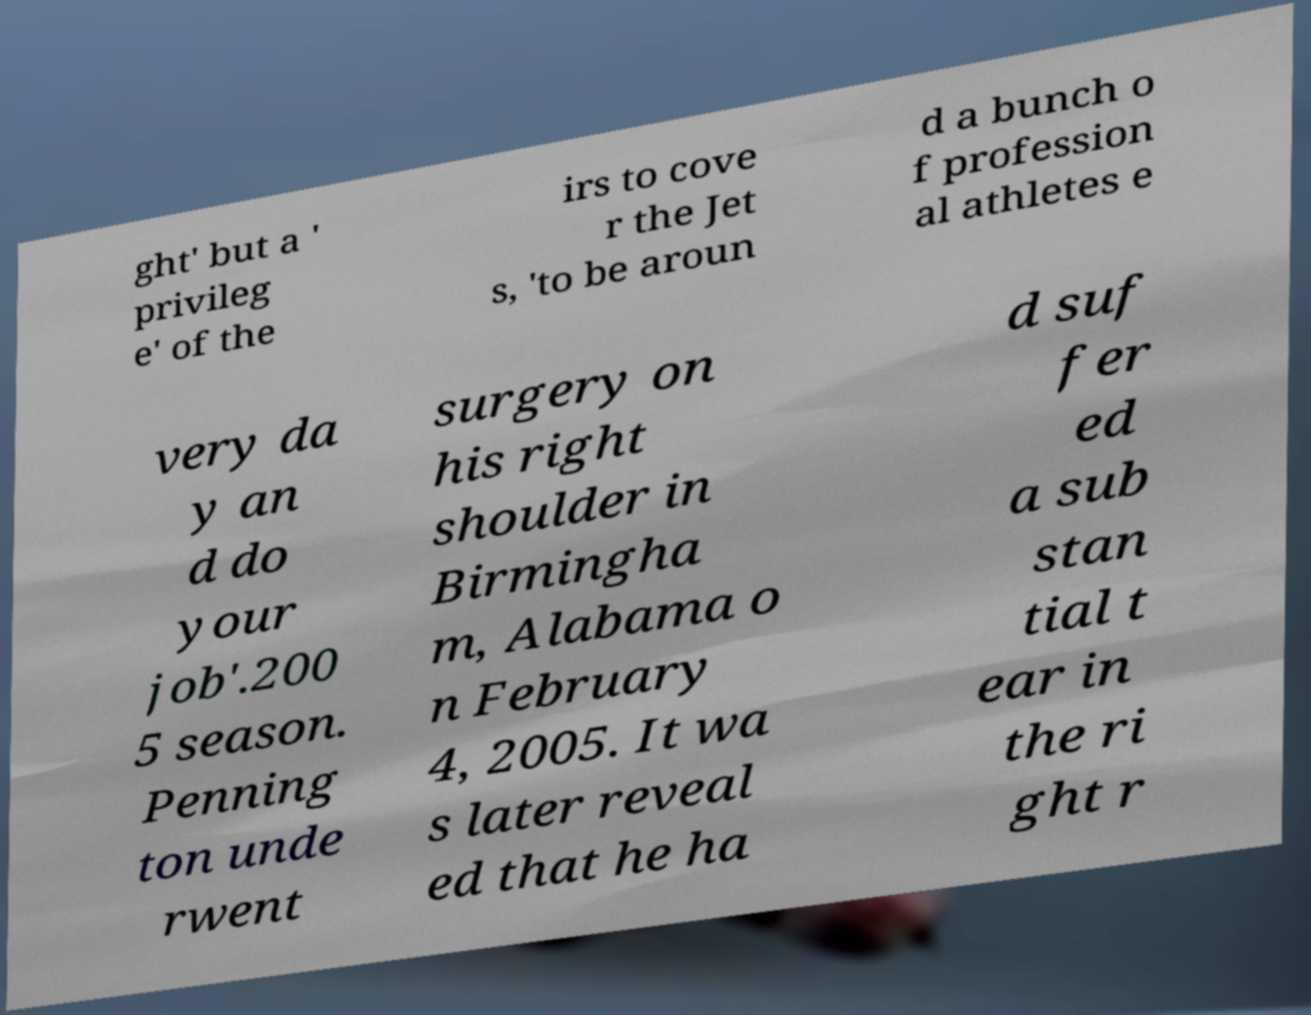Can you accurately transcribe the text from the provided image for me? ght' but a ' privileg e' of the irs to cove r the Jet s, 'to be aroun d a bunch o f profession al athletes e very da y an d do your job'.200 5 season. Penning ton unde rwent surgery on his right shoulder in Birmingha m, Alabama o n February 4, 2005. It wa s later reveal ed that he ha d suf fer ed a sub stan tial t ear in the ri ght r 